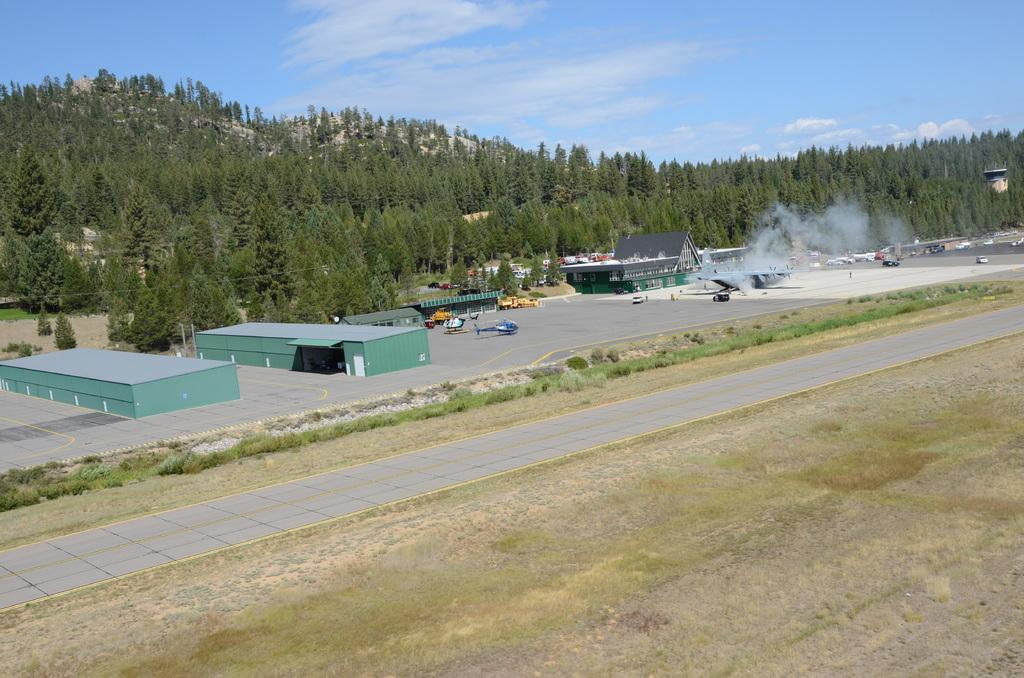What is the main feature of the image? There is a road in the image. What can be seen beside the road? There are houses beside the road. What types of transportation are visible in the image? There are vehicles in the image. Can you describe the presence of a flying object in the image? There is a helicopter in the image. What is visible at the top of the image? The sky is visible at the top of the image. What type of natural features can be seen in the image? There are hills and trees in the image. What type of scarecrow is standing in the middle of the road in the image? There is no scarecrow present in the image; it features a road, houses, vehicles, a helicopter, the sky, hills, and trees. What is the tax rate for the houses in the image? There is no information about tax rates in the image; it only shows a road, houses, vehicles, a helicopter, the sky, hills, and trees. 